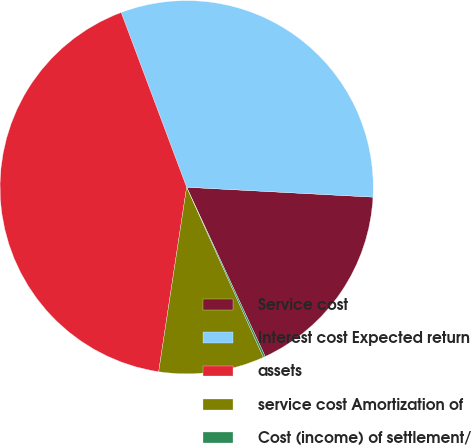Convert chart. <chart><loc_0><loc_0><loc_500><loc_500><pie_chart><fcel>Service cost<fcel>Interest cost Expected return<fcel>assets<fcel>service cost Amortization of<fcel>Cost (income) of settlement/<nl><fcel>17.24%<fcel>31.55%<fcel>41.9%<fcel>9.14%<fcel>0.17%<nl></chart> 